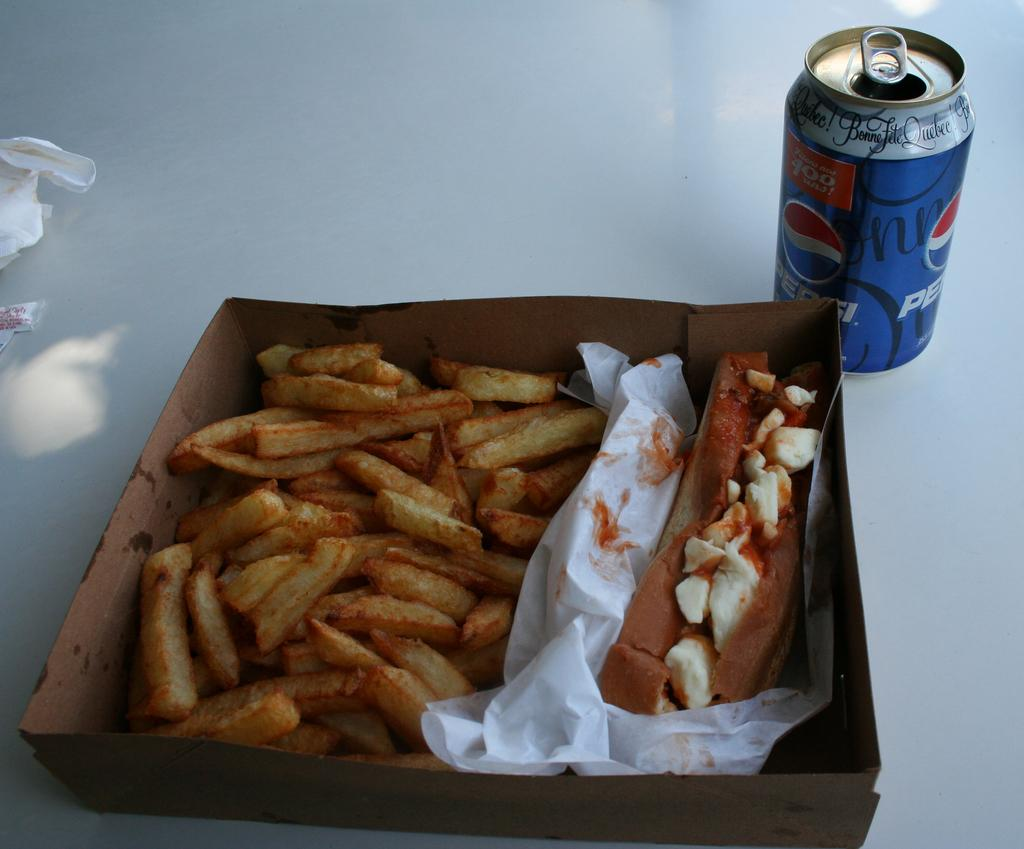What type of food is in the box in the image? There are french fries in a box in the image. What beverage is present in the image? There is a coke tin in the image. What color is the surface on which the coke tin is placed? The coke tin is on a white surface. How many planes can be seen flying over the field in the image? There are no planes or fields present in the image. Is there a gun visible on the white surface in the image? There is no gun present in the image. 